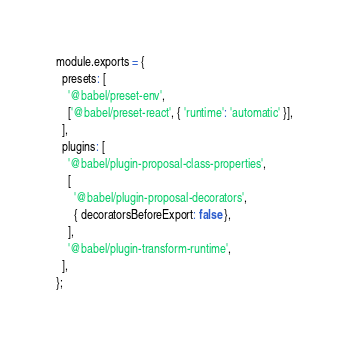Convert code to text. <code><loc_0><loc_0><loc_500><loc_500><_JavaScript_>module.exports = {
  presets: [
    '@babel/preset-env',
    ['@babel/preset-react', { 'runtime': 'automatic' }],
  ],
  plugins: [
    '@babel/plugin-proposal-class-properties',
    [
      '@babel/plugin-proposal-decorators',
      { decoratorsBeforeExport: false },
    ],
    '@babel/plugin-transform-runtime',
  ],
};
</code> 